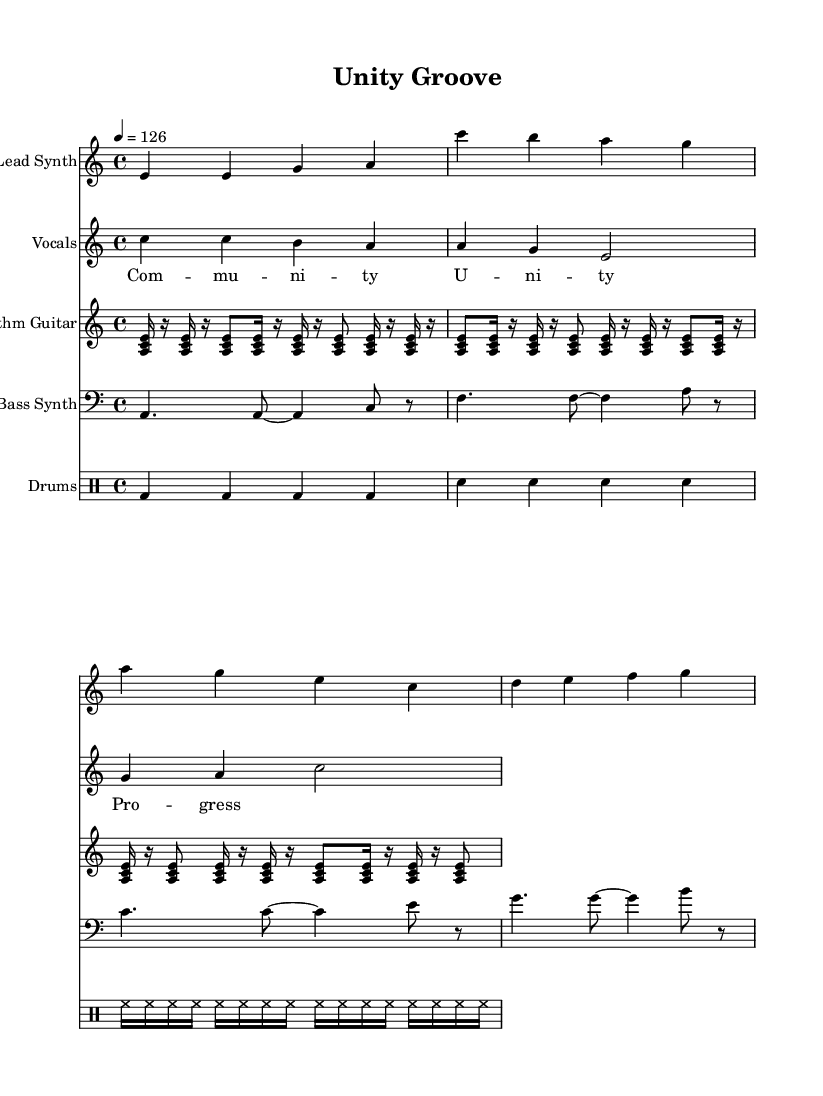What is the key signature of this music? The key signature is indicated at the beginning of the staff with the letter 'a' in lowercase and 'minor' written, meaning the music is in the key of A minor.
Answer: A minor What is the time signature of this music? The time signature is found right at the beginning of the staff, represented at the start by "4/4", which indicates that there are four beats in a measure.
Answer: 4/4 What is the tempo of this composition? The tempo marking, indicated by "4 = 126", shows that the quarter note is set to 126 beats per minute, defining how fast the music should be played.
Answer: 126 How many measures are in the lead synth part? By counting the individual measure lines in the lead synth staff, there are a total of four measures present in the sheet music.
Answer: 4 What type of instrument is the bass synth part notated for? The clef at the beginning of the bass synth part is indicated by the symbol "bass" which identifies that this part is written for bass instruments.
Answer: Bass What are the dynamics indicated for the vocals? The vocal part does not show any specific dynamic markings or symbols, which typically means it should be played with a standard volume unless indicated otherwise.
Answer: None How is community unity represented in the lyrics of this song? The lyrics mention the word "Community" followed by "Unity" and "Progress," directly reflecting the theme of togetherness and social advancement, which embodies the spirit of community.
Answer: Community Unity Progress 